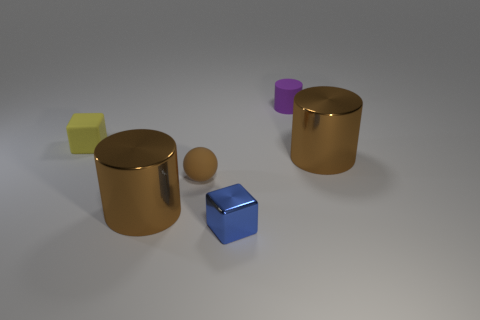Is the small purple cylinder made of the same material as the large thing to the left of the tiny blue metallic block? The small purple cylinder appears to have a matte surface which is indicative of a plastic-like material, whereas the large object to the left of the tiny blue block has a reflective metallic surface. Despite the difference in size and color, it's the material properties that suggest they are not made of the same substance. 